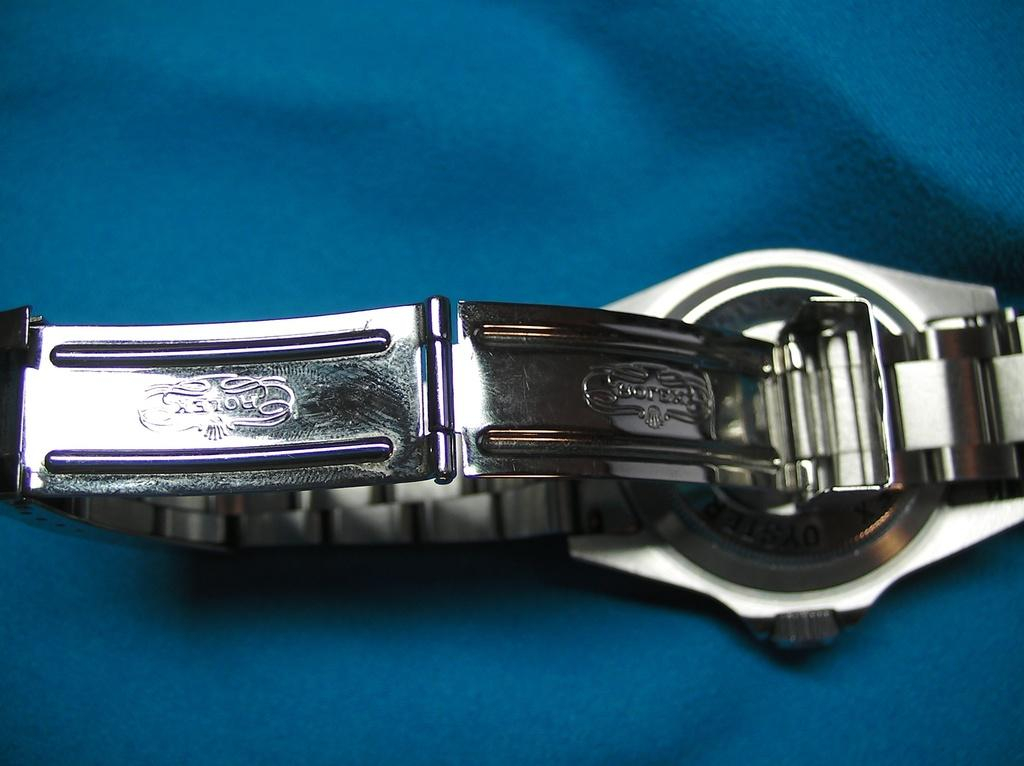<image>
Provide a brief description of the given image. Backside of a silver rolex watch that shows the logo on the chain. 